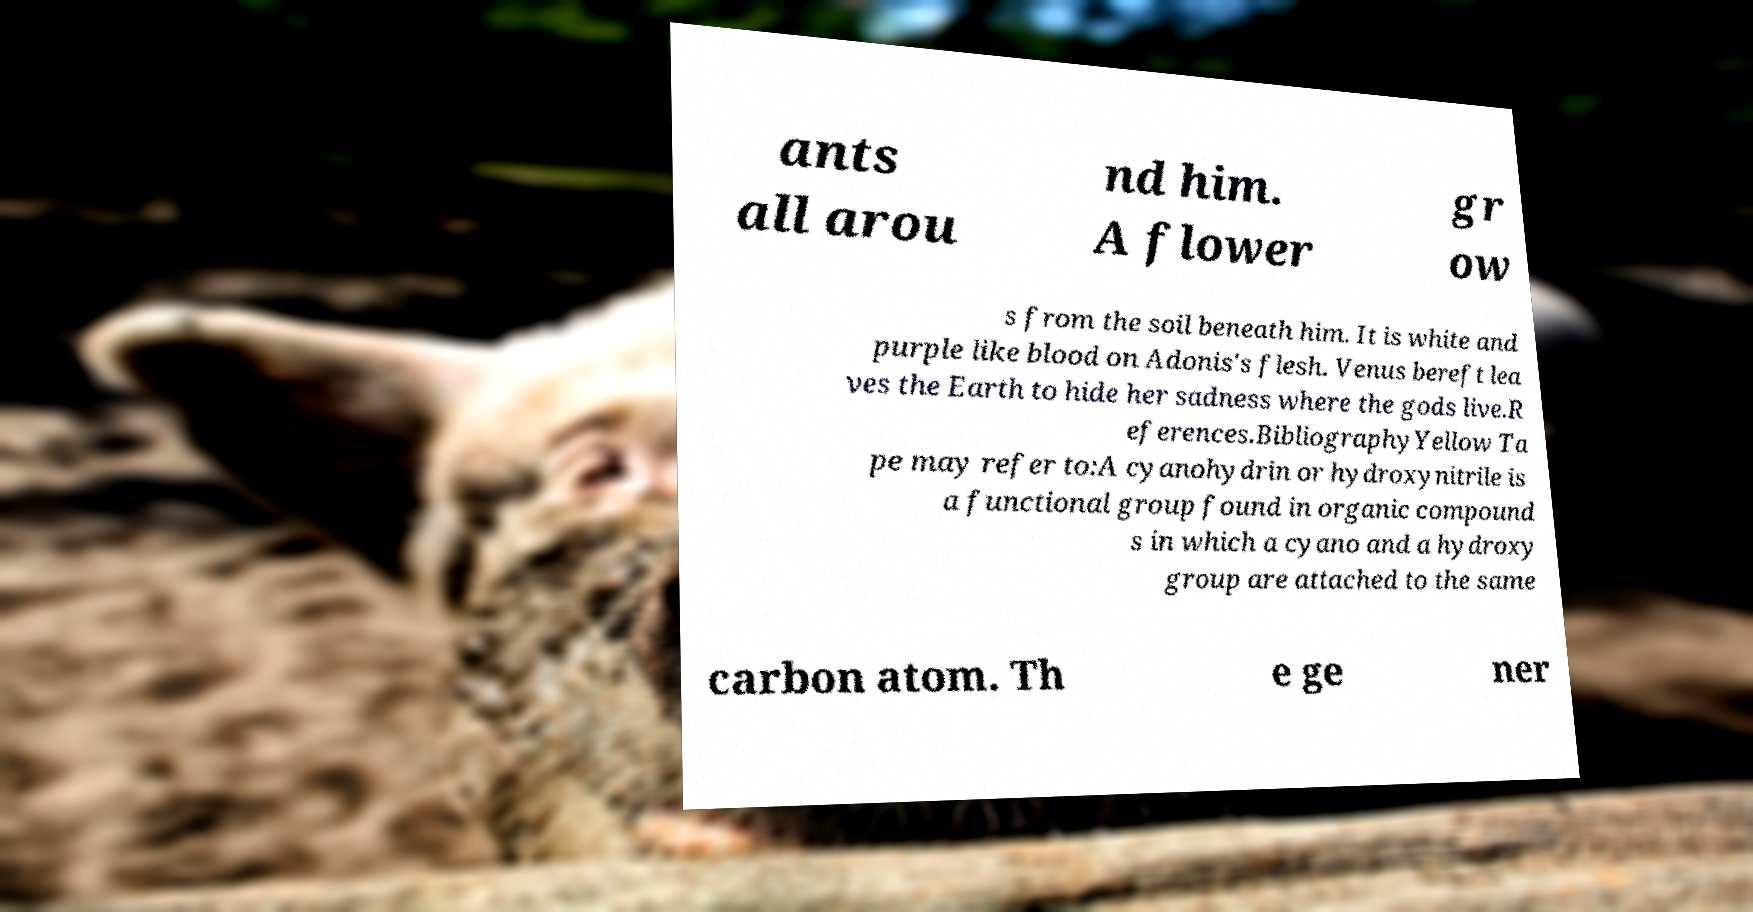Could you assist in decoding the text presented in this image and type it out clearly? ants all arou nd him. A flower gr ow s from the soil beneath him. It is white and purple like blood on Adonis's flesh. Venus bereft lea ves the Earth to hide her sadness where the gods live.R eferences.BibliographyYellow Ta pe may refer to:A cyanohydrin or hydroxynitrile is a functional group found in organic compound s in which a cyano and a hydroxy group are attached to the same carbon atom. Th e ge ner 